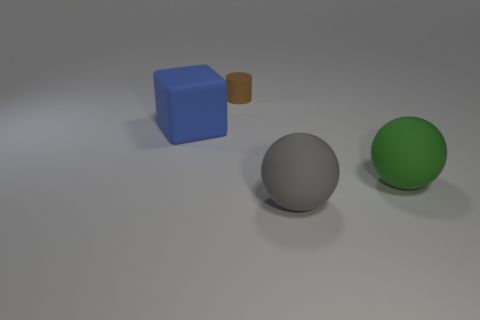Add 1 large yellow matte cylinders. How many objects exist? 5 Subtract all cylinders. How many objects are left? 3 Subtract 1 blue blocks. How many objects are left? 3 Subtract all large green metallic objects. Subtract all large matte spheres. How many objects are left? 2 Add 2 blue blocks. How many blue blocks are left? 3 Add 1 brown metallic cylinders. How many brown metallic cylinders exist? 1 